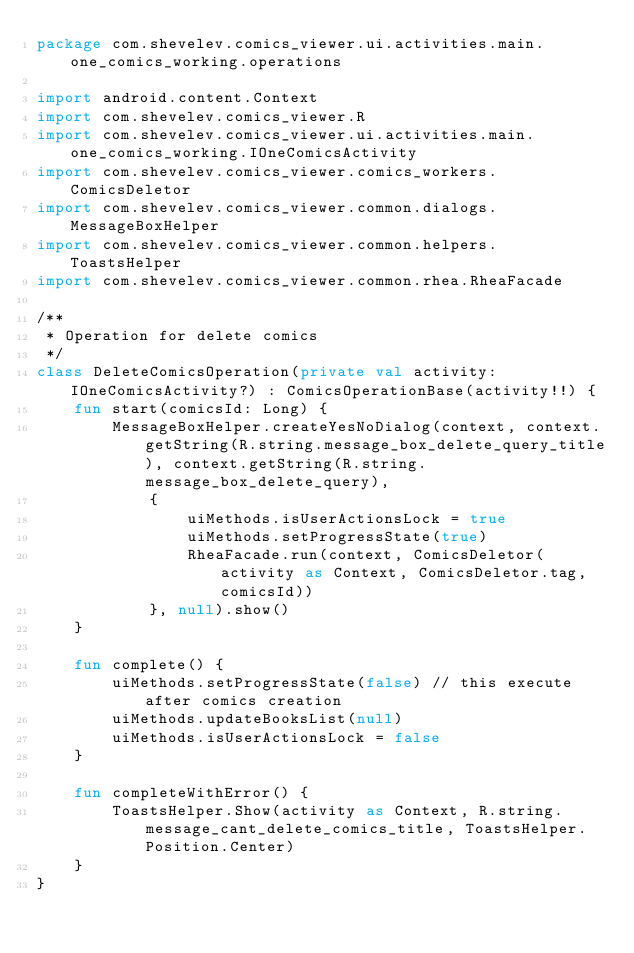Convert code to text. <code><loc_0><loc_0><loc_500><loc_500><_Kotlin_>package com.shevelev.comics_viewer.ui.activities.main.one_comics_working.operations

import android.content.Context
import com.shevelev.comics_viewer.R
import com.shevelev.comics_viewer.ui.activities.main.one_comics_working.IOneComicsActivity
import com.shevelev.comics_viewer.comics_workers.ComicsDeletor
import com.shevelev.comics_viewer.common.dialogs.MessageBoxHelper
import com.shevelev.comics_viewer.common.helpers.ToastsHelper
import com.shevelev.comics_viewer.common.rhea.RheaFacade

/**
 * Operation for delete comics
 */
class DeleteComicsOperation(private val activity: IOneComicsActivity?) : ComicsOperationBase(activity!!) {
    fun start(comicsId: Long) {
        MessageBoxHelper.createYesNoDialog(context, context.getString(R.string.message_box_delete_query_title), context.getString(R.string.message_box_delete_query),
            {
                uiMethods.isUserActionsLock = true
                uiMethods.setProgressState(true)
                RheaFacade.run(context, ComicsDeletor(activity as Context, ComicsDeletor.tag, comicsId))
            }, null).show()
    }

    fun complete() {
        uiMethods.setProgressState(false) // this execute after comics creation
        uiMethods.updateBooksList(null)
        uiMethods.isUserActionsLock = false
    }

    fun completeWithError() {
        ToastsHelper.Show(activity as Context, R.string.message_cant_delete_comics_title, ToastsHelper.Position.Center)
    }
}</code> 